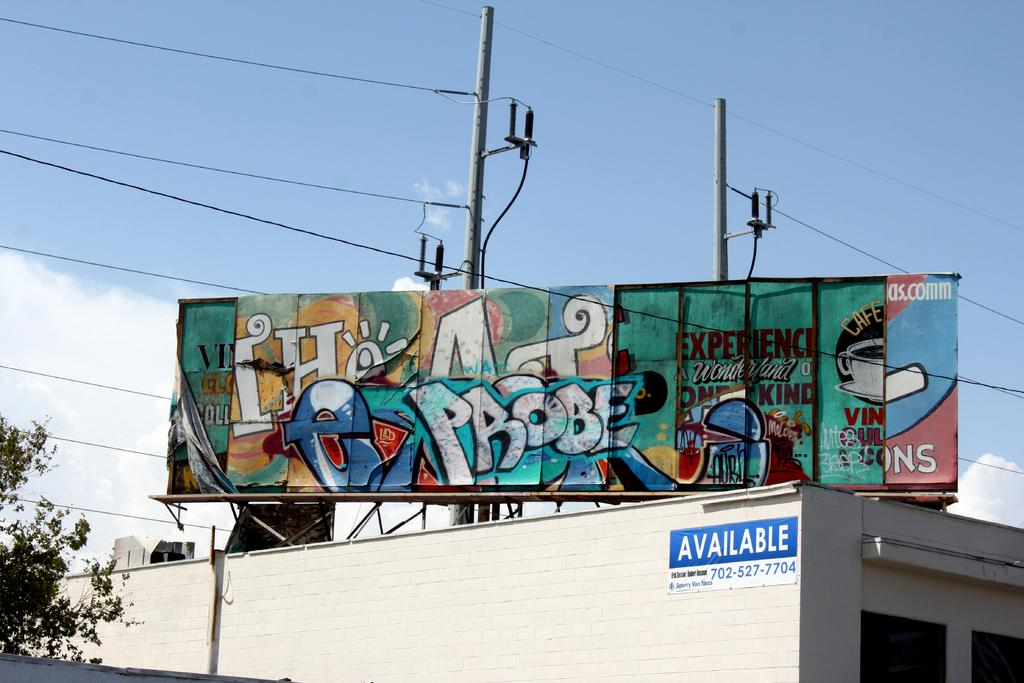Provide a one-sentence caption for the provided image. A graffiti covered billboard eith the word Probe in the middle. 